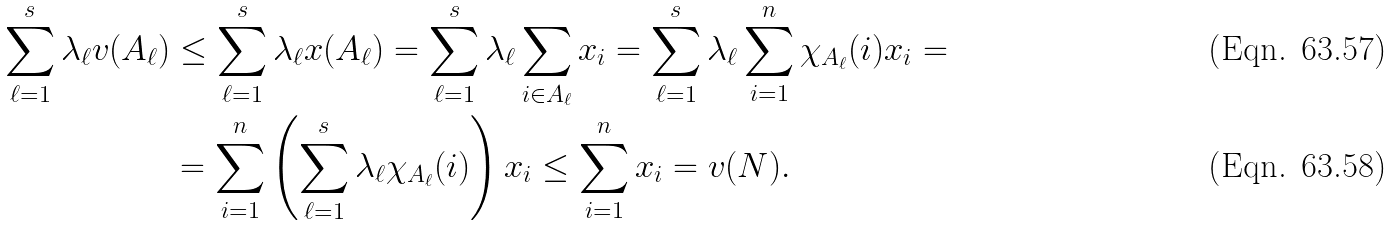<formula> <loc_0><loc_0><loc_500><loc_500>\sum _ { \ell = 1 } ^ { s } \lambda _ { \ell } v ( A _ { \ell } ) & \leq \sum _ { \ell = 1 } ^ { s } \lambda _ { \ell } x ( A _ { \ell } ) = \sum _ { \ell = 1 } ^ { s } \lambda _ { \ell } \sum _ { i \in A _ { \ell } } x _ { i } = \sum _ { \ell = 1 } ^ { s } \lambda _ { \ell } \sum _ { i = 1 } ^ { n } \chi _ { A _ { \ell } } ( i ) x _ { i } = \\ & = \sum _ { i = 1 } ^ { n } \left ( \sum _ { \ell = 1 } ^ { s } \lambda _ { \ell } \chi _ { A _ { \ell } } ( i ) \right ) x _ { i } \leq \sum _ { i = 1 } ^ { n } x _ { i } = v ( N ) .</formula> 